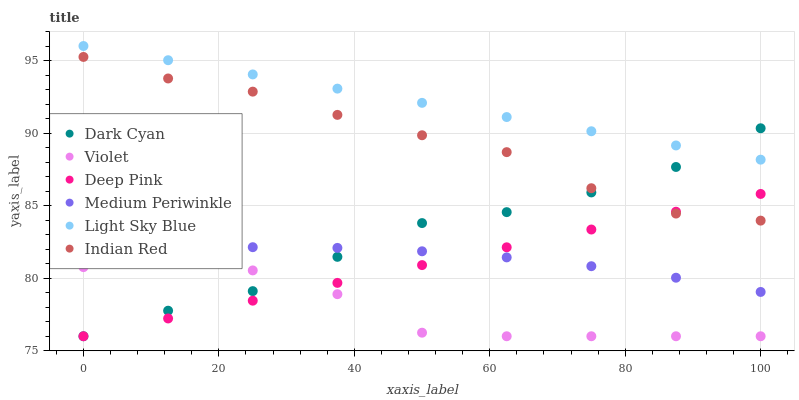Does Violet have the minimum area under the curve?
Answer yes or no. Yes. Does Light Sky Blue have the maximum area under the curve?
Answer yes or no. Yes. Does Medium Periwinkle have the minimum area under the curve?
Answer yes or no. No. Does Medium Periwinkle have the maximum area under the curve?
Answer yes or no. No. Is Deep Pink the smoothest?
Answer yes or no. Yes. Is Violet the roughest?
Answer yes or no. Yes. Is Medium Periwinkle the smoothest?
Answer yes or no. No. Is Medium Periwinkle the roughest?
Answer yes or no. No. Does Deep Pink have the lowest value?
Answer yes or no. Yes. Does Medium Periwinkle have the lowest value?
Answer yes or no. No. Does Light Sky Blue have the highest value?
Answer yes or no. Yes. Does Medium Periwinkle have the highest value?
Answer yes or no. No. Is Medium Periwinkle less than Indian Red?
Answer yes or no. Yes. Is Light Sky Blue greater than Violet?
Answer yes or no. Yes. Does Deep Pink intersect Medium Periwinkle?
Answer yes or no. Yes. Is Deep Pink less than Medium Periwinkle?
Answer yes or no. No. Is Deep Pink greater than Medium Periwinkle?
Answer yes or no. No. Does Medium Periwinkle intersect Indian Red?
Answer yes or no. No. 